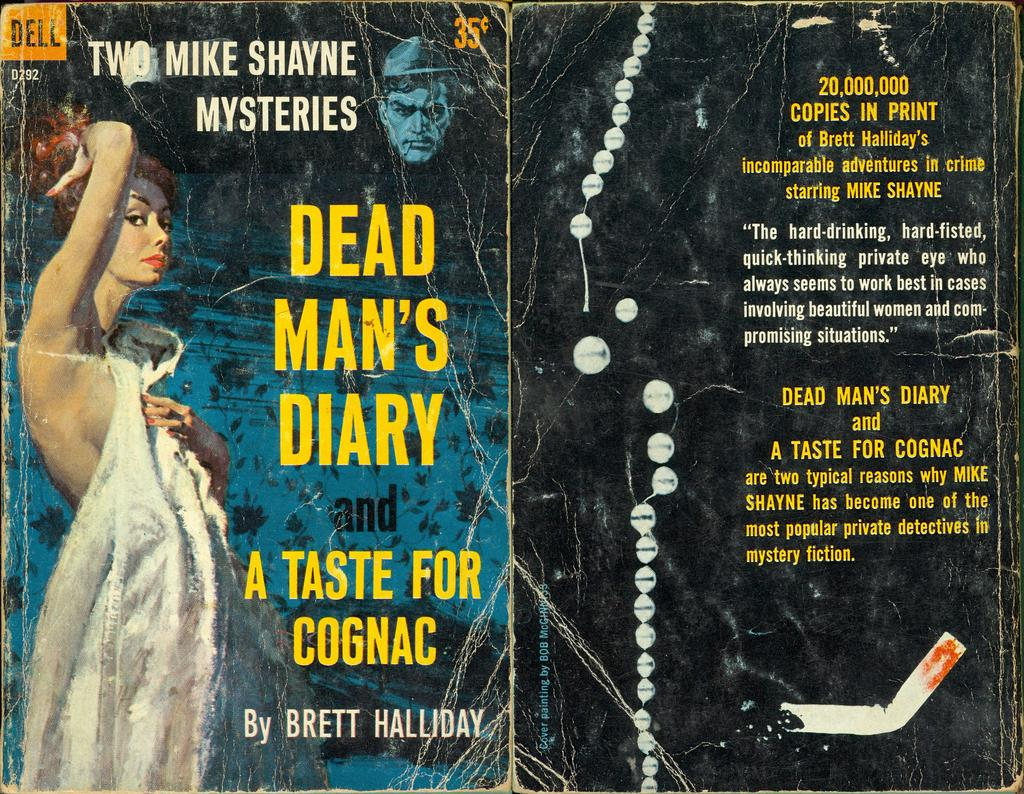<image>
Render a clear and concise summary of the photo. A book cover has the code D292 on the front cover. 